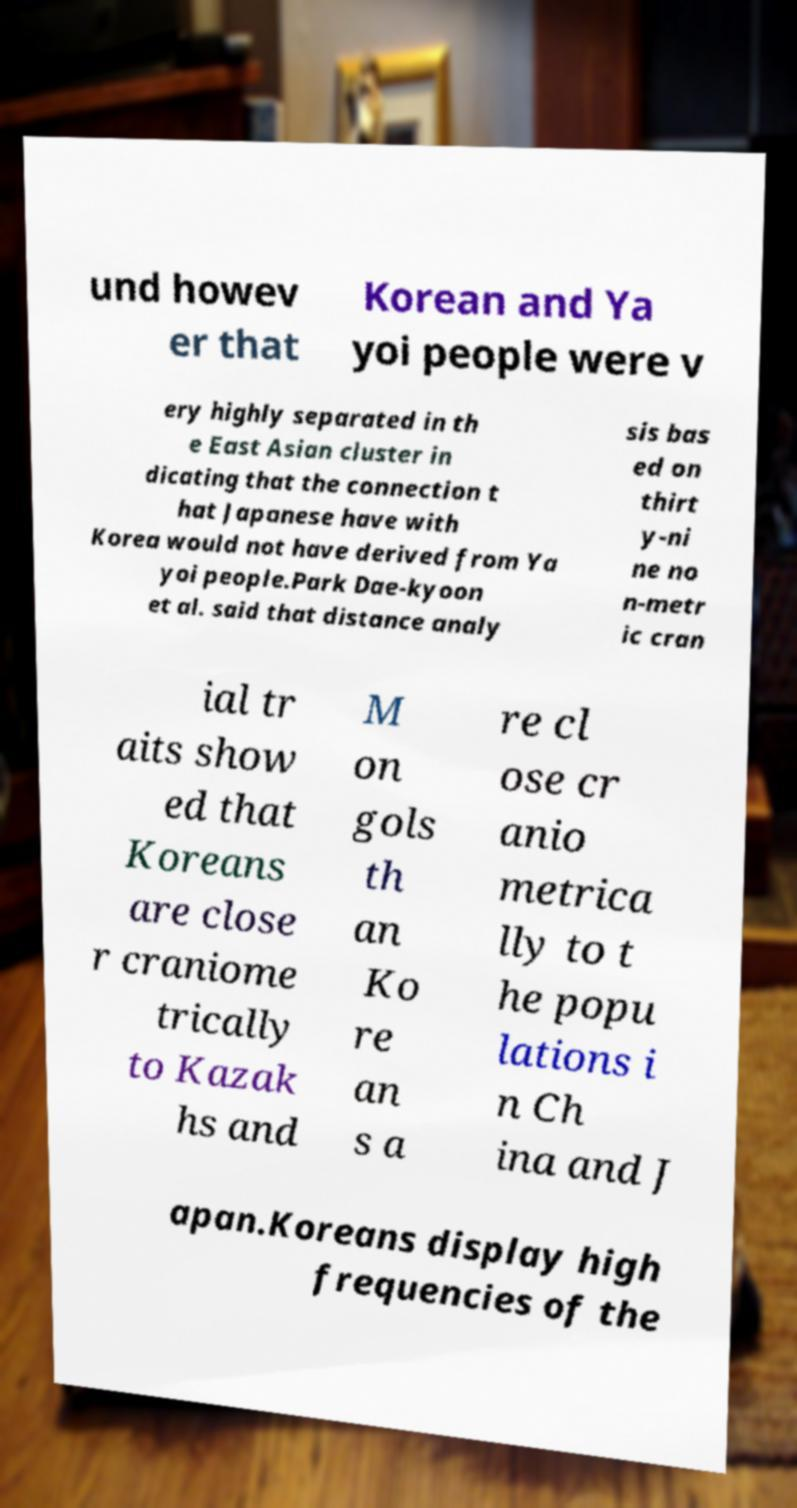Could you extract and type out the text from this image? und howev er that Korean and Ya yoi people were v ery highly separated in th e East Asian cluster in dicating that the connection t hat Japanese have with Korea would not have derived from Ya yoi people.Park Dae-kyoon et al. said that distance analy sis bas ed on thirt y-ni ne no n-metr ic cran ial tr aits show ed that Koreans are close r craniome trically to Kazak hs and M on gols th an Ko re an s a re cl ose cr anio metrica lly to t he popu lations i n Ch ina and J apan.Koreans display high frequencies of the 